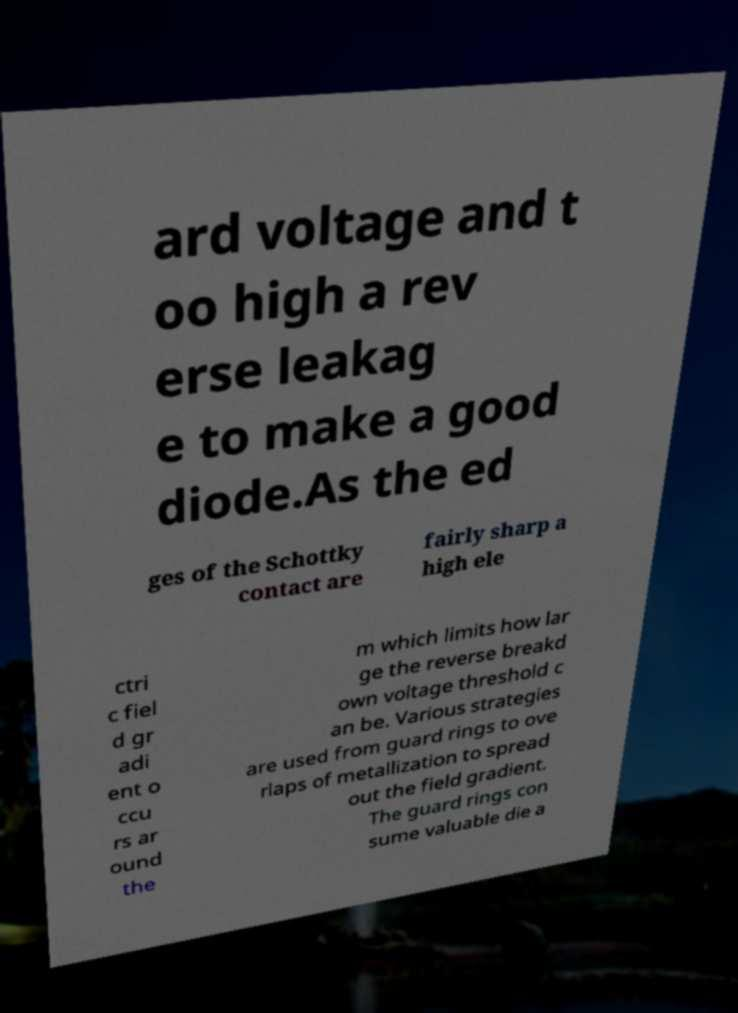Can you read and provide the text displayed in the image?This photo seems to have some interesting text. Can you extract and type it out for me? ard voltage and t oo high a rev erse leakag e to make a good diode.As the ed ges of the Schottky contact are fairly sharp a high ele ctri c fiel d gr adi ent o ccu rs ar ound the m which limits how lar ge the reverse breakd own voltage threshold c an be. Various strategies are used from guard rings to ove rlaps of metallization to spread out the field gradient. The guard rings con sume valuable die a 